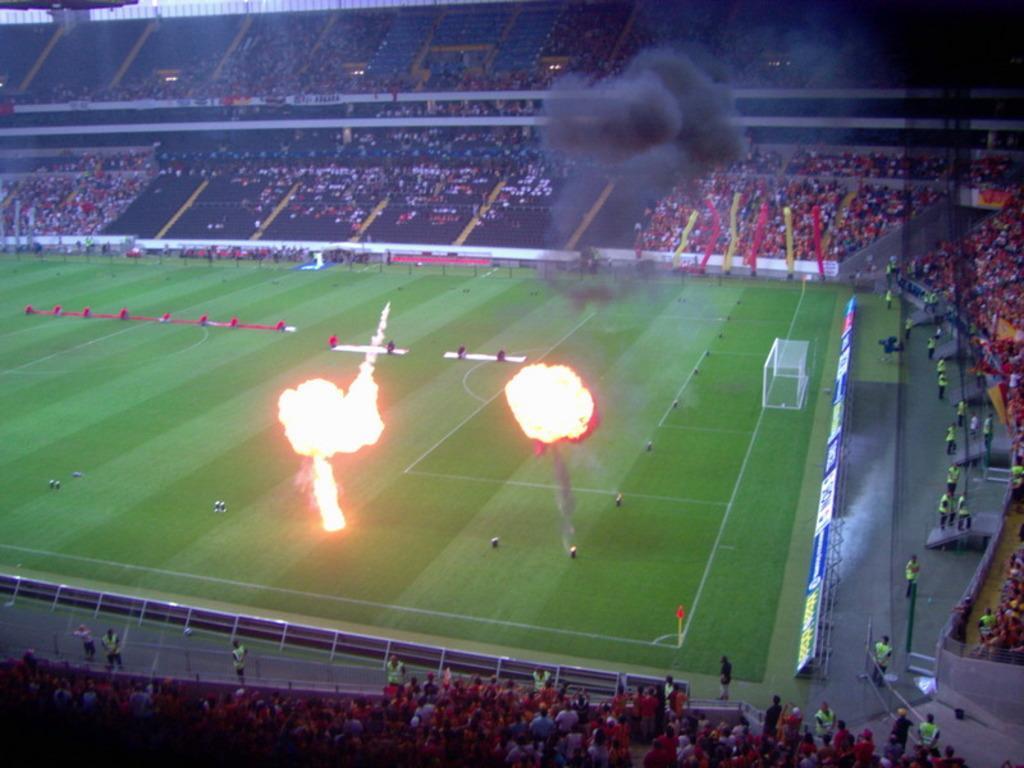Can you describe this image briefly? In this image I can see fire in the middle of playground, around that there are so many people in the stadium. 